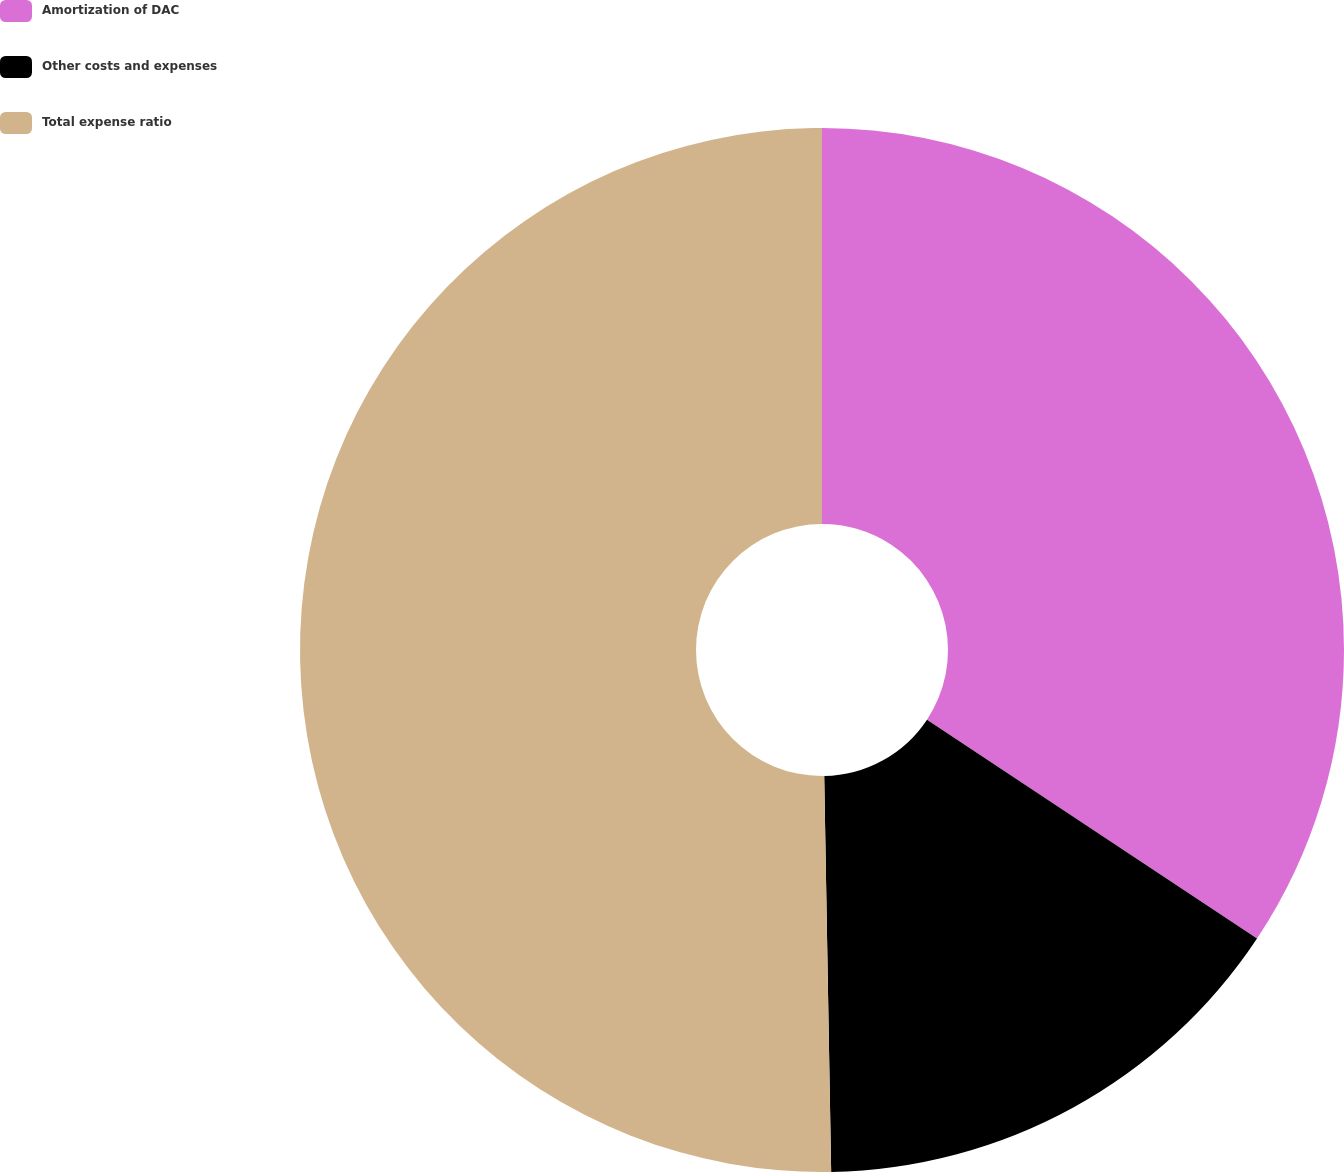Convert chart to OTSL. <chart><loc_0><loc_0><loc_500><loc_500><pie_chart><fcel>Amortization of DAC<fcel>Other costs and expenses<fcel>Total expense ratio<nl><fcel>34.32%<fcel>15.4%<fcel>50.28%<nl></chart> 